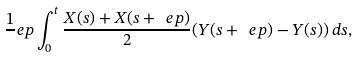<formula> <loc_0><loc_0><loc_500><loc_500>\frac { 1 } { \ } e p \int _ { 0 } ^ { t } \frac { X ( s ) + X ( s + \ e p ) } 2 ( Y ( s + \ e p ) - Y ( s ) ) \, d s ,</formula> 